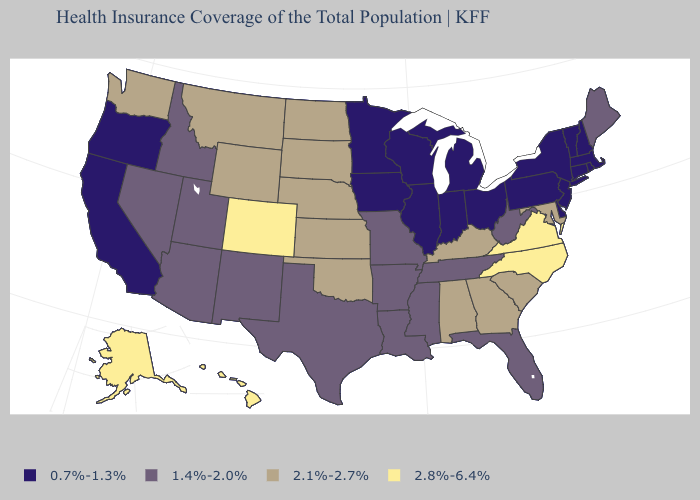What is the value of Ohio?
Concise answer only. 0.7%-1.3%. Does North Carolina have the highest value in the South?
Quick response, please. Yes. Name the states that have a value in the range 0.7%-1.3%?
Give a very brief answer. California, Connecticut, Delaware, Illinois, Indiana, Iowa, Massachusetts, Michigan, Minnesota, New Hampshire, New Jersey, New York, Ohio, Oregon, Pennsylvania, Rhode Island, Vermont, Wisconsin. What is the value of Kansas?
Keep it brief. 2.1%-2.7%. Name the states that have a value in the range 0.7%-1.3%?
Write a very short answer. California, Connecticut, Delaware, Illinois, Indiana, Iowa, Massachusetts, Michigan, Minnesota, New Hampshire, New Jersey, New York, Ohio, Oregon, Pennsylvania, Rhode Island, Vermont, Wisconsin. Which states have the lowest value in the USA?
Give a very brief answer. California, Connecticut, Delaware, Illinois, Indiana, Iowa, Massachusetts, Michigan, Minnesota, New Hampshire, New Jersey, New York, Ohio, Oregon, Pennsylvania, Rhode Island, Vermont, Wisconsin. Name the states that have a value in the range 0.7%-1.3%?
Short answer required. California, Connecticut, Delaware, Illinois, Indiana, Iowa, Massachusetts, Michigan, Minnesota, New Hampshire, New Jersey, New York, Ohio, Oregon, Pennsylvania, Rhode Island, Vermont, Wisconsin. Among the states that border Kentucky , which have the highest value?
Concise answer only. Virginia. Does New Mexico have the lowest value in the West?
Be succinct. No. What is the value of Montana?
Give a very brief answer. 2.1%-2.7%. What is the lowest value in the West?
Concise answer only. 0.7%-1.3%. What is the lowest value in the USA?
Keep it brief. 0.7%-1.3%. Name the states that have a value in the range 2.1%-2.7%?
Quick response, please. Alabama, Georgia, Kansas, Kentucky, Maryland, Montana, Nebraska, North Dakota, Oklahoma, South Carolina, South Dakota, Washington, Wyoming. Does North Carolina have the highest value in the South?
Keep it brief. Yes. What is the value of Wisconsin?
Give a very brief answer. 0.7%-1.3%. 